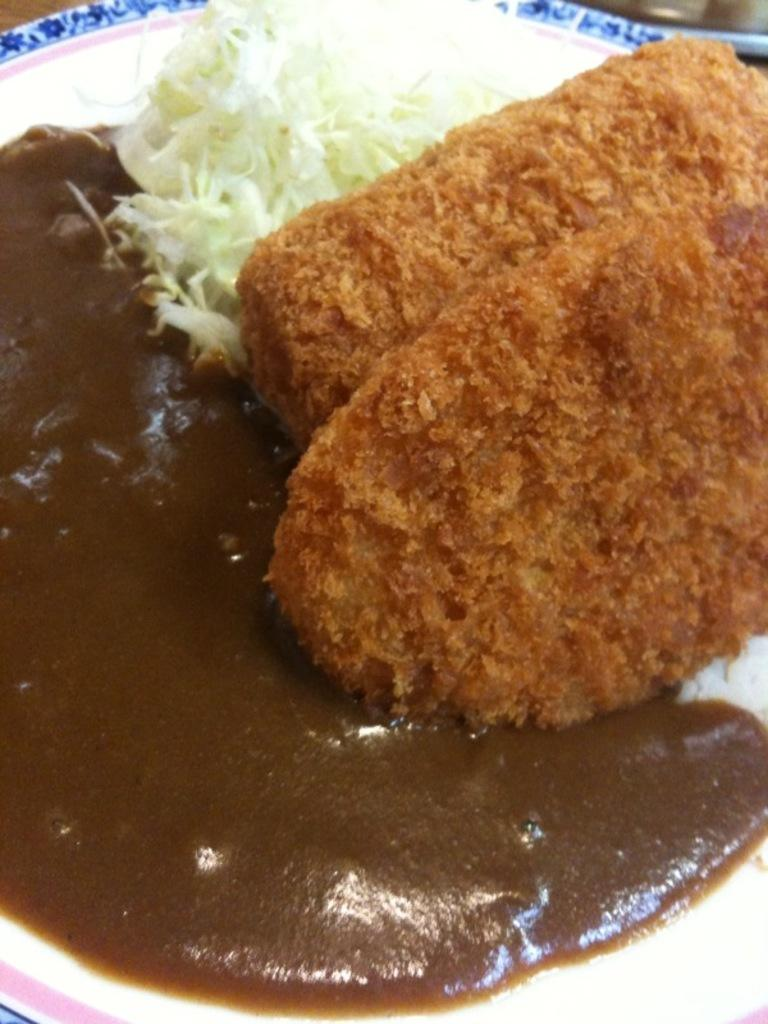What object is present on the plate in the image? There is a white plate in the image. What is on top of the plate? There is food on the plate. Can you describe the appearance of the food? The food has brown and white colors. How does the rainstorm affect the food on the plate in the image? There is no rainstorm present in the image, so it cannot affect the food on the plate. 